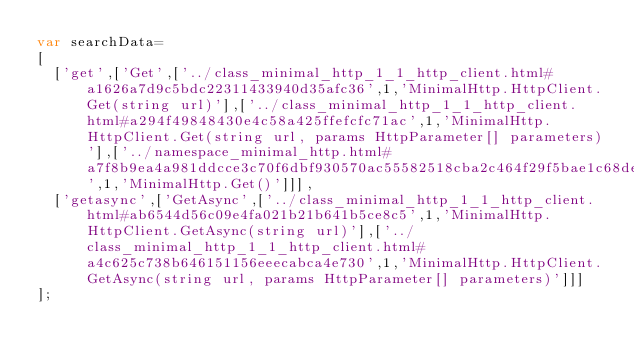<code> <loc_0><loc_0><loc_500><loc_500><_JavaScript_>var searchData=
[
  ['get',['Get',['../class_minimal_http_1_1_http_client.html#a1626a7d9c5bdc22311433940d35afc36',1,'MinimalHttp.HttpClient.Get(string url)'],['../class_minimal_http_1_1_http_client.html#a294f49848430e4c58a425ffefcfc71ac',1,'MinimalHttp.HttpClient.Get(string url, params HttpParameter[] parameters)'],['../namespace_minimal_http.html#a7f8b9ea4a981ddcce3c70f6dbf930570ac55582518cba2c464f29f5bae1c68def',1,'MinimalHttp.Get()']]],
  ['getasync',['GetAsync',['../class_minimal_http_1_1_http_client.html#ab6544d56c09e4fa021b21b641b5ce8c5',1,'MinimalHttp.HttpClient.GetAsync(string url)'],['../class_minimal_http_1_1_http_client.html#a4c625c738b646151156eeecabca4e730',1,'MinimalHttp.HttpClient.GetAsync(string url, params HttpParameter[] parameters)']]]
];
</code> 